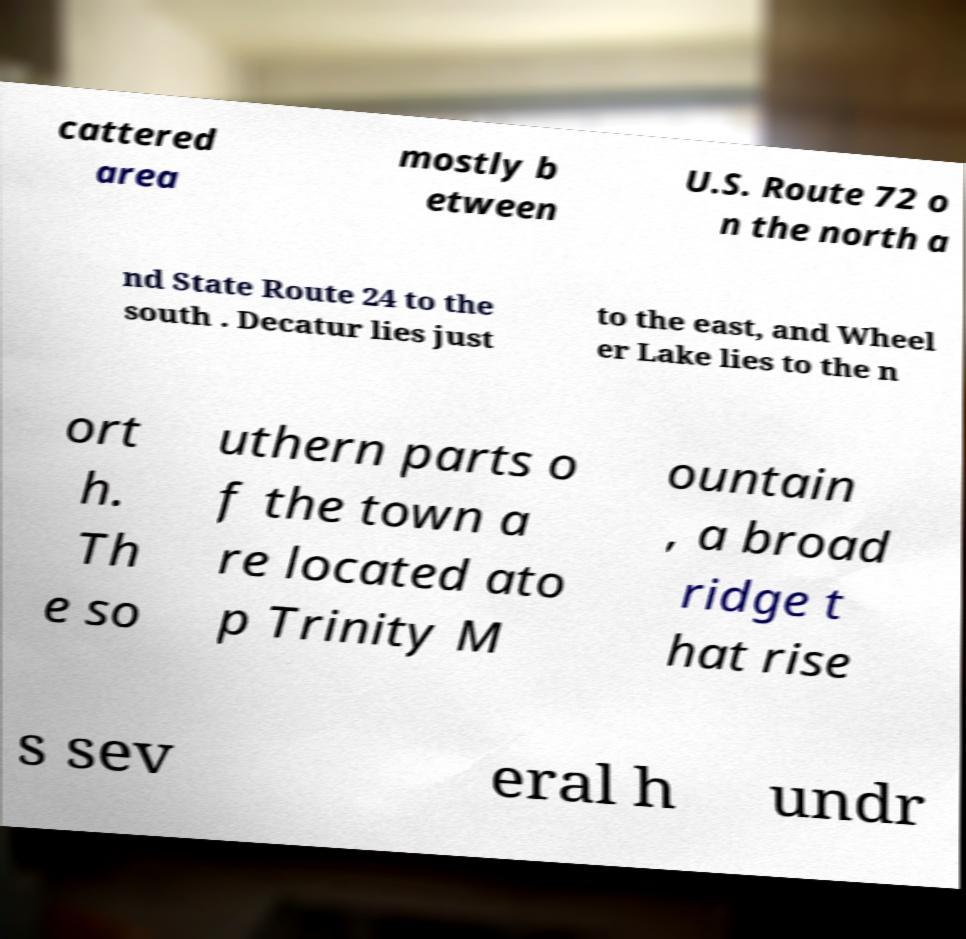Could you assist in decoding the text presented in this image and type it out clearly? cattered area mostly b etween U.S. Route 72 o n the north a nd State Route 24 to the south . Decatur lies just to the east, and Wheel er Lake lies to the n ort h. Th e so uthern parts o f the town a re located ato p Trinity M ountain , a broad ridge t hat rise s sev eral h undr 